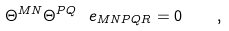<formula> <loc_0><loc_0><loc_500><loc_500>\Theta ^ { M N } \Theta ^ { P Q } \ e _ { M N P Q R } = 0 \quad ,</formula> 